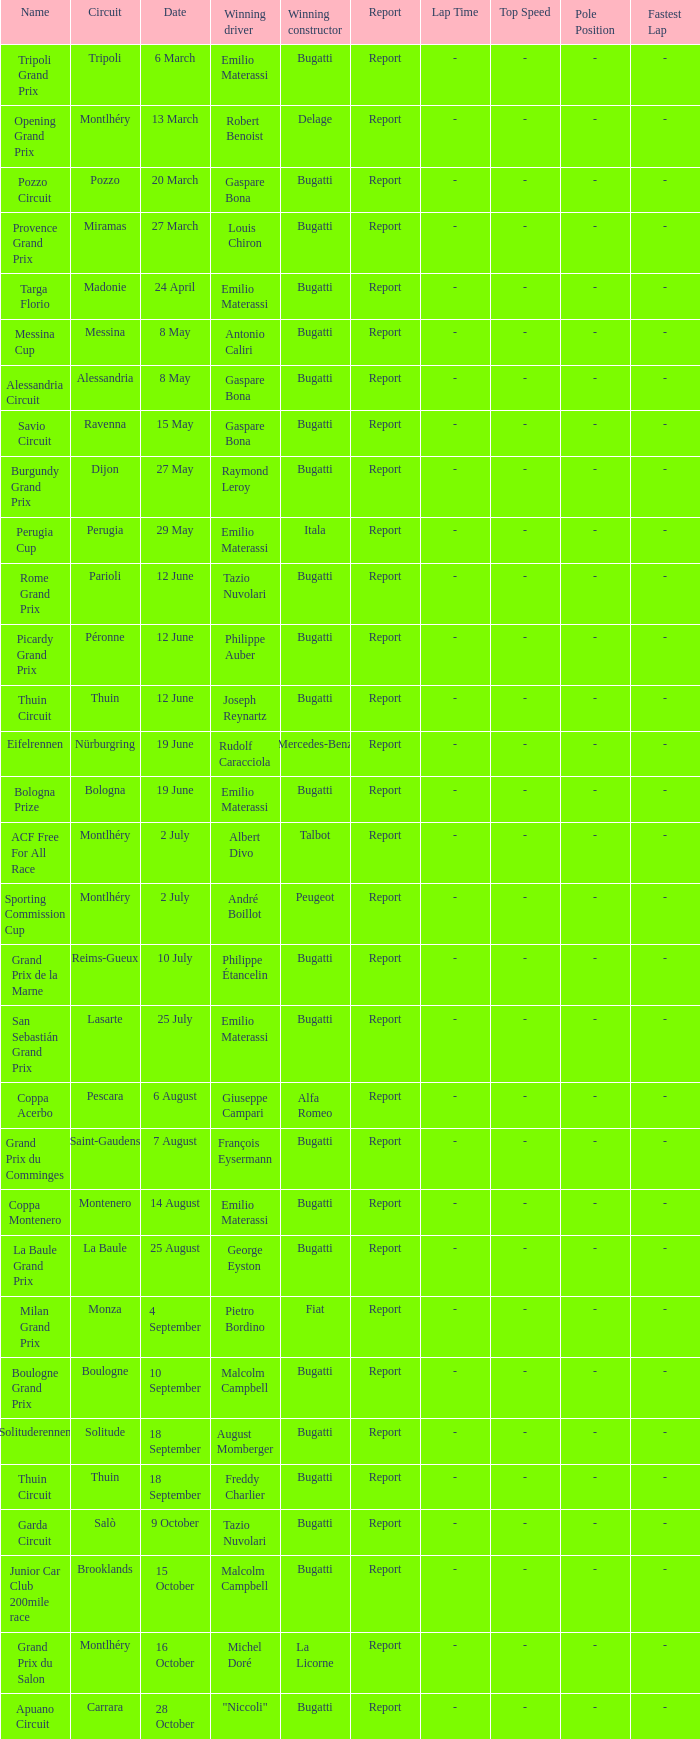At the circuit of parioli, which constructor emerged as the winner? Bugatti. 